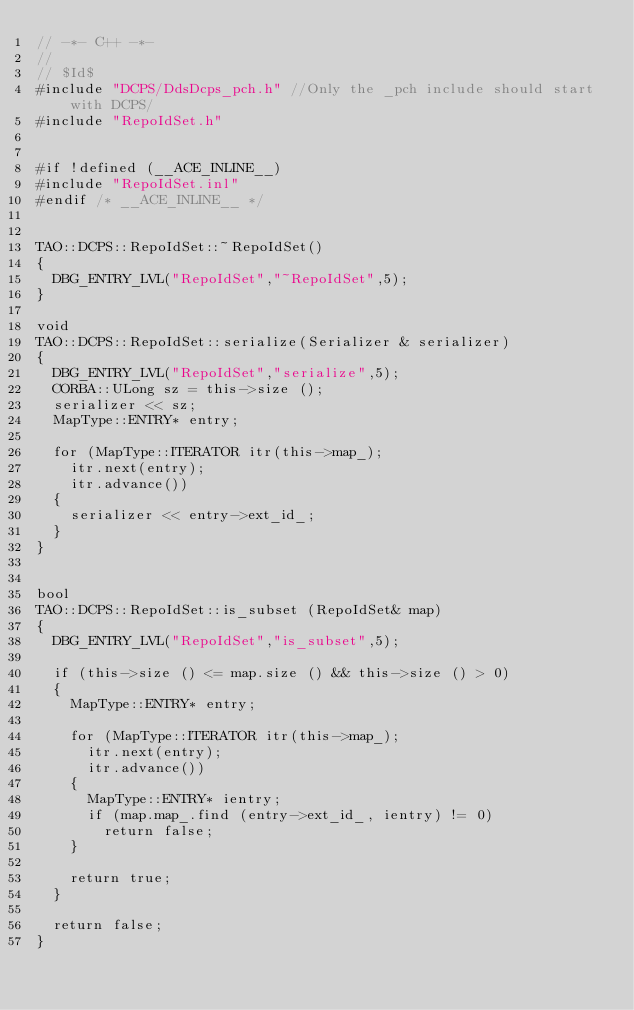<code> <loc_0><loc_0><loc_500><loc_500><_C++_>// -*- C++ -*-
//
// $Id$
#include "DCPS/DdsDcps_pch.h" //Only the _pch include should start with DCPS/
#include "RepoIdSet.h"


#if !defined (__ACE_INLINE__)
#include "RepoIdSet.inl"
#endif /* __ACE_INLINE__ */


TAO::DCPS::RepoIdSet::~RepoIdSet()
{
  DBG_ENTRY_LVL("RepoIdSet","~RepoIdSet",5);
}

void
TAO::DCPS::RepoIdSet::serialize(Serializer & serializer)
{
  DBG_ENTRY_LVL("RepoIdSet","serialize",5);
  CORBA::ULong sz = this->size ();
  serializer << sz;
  MapType::ENTRY* entry;

  for (MapType::ITERATOR itr(this->map_);
    itr.next(entry);
    itr.advance())
  {
    serializer << entry->ext_id_;
  }
}


bool
TAO::DCPS::RepoIdSet::is_subset (RepoIdSet& map)
{
  DBG_ENTRY_LVL("RepoIdSet","is_subset",5);

  if (this->size () <= map.size () && this->size () > 0)
  {
    MapType::ENTRY* entry;

    for (MapType::ITERATOR itr(this->map_);
      itr.next(entry);
      itr.advance())
    {
      MapType::ENTRY* ientry;
      if (map.map_.find (entry->ext_id_, ientry) != 0)
        return false;
    }

    return true;
  }

  return false;
}

</code> 